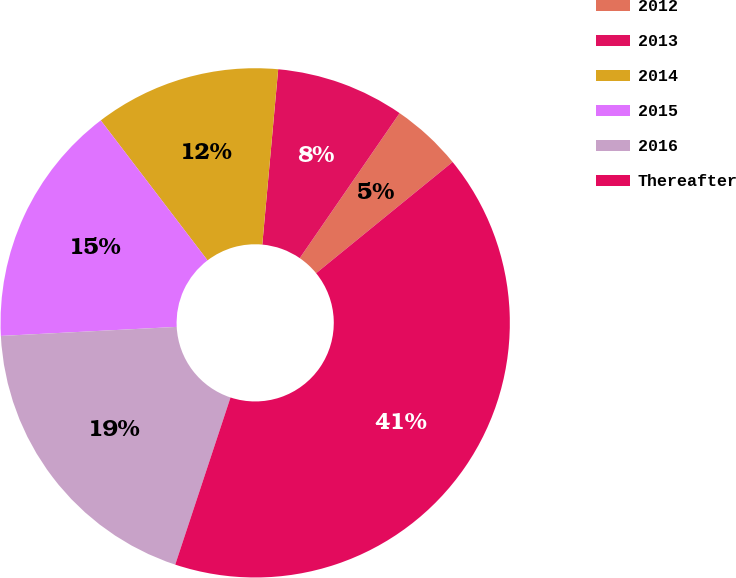Convert chart to OTSL. <chart><loc_0><loc_0><loc_500><loc_500><pie_chart><fcel>2012<fcel>2013<fcel>2014<fcel>2015<fcel>2016<fcel>Thereafter<nl><fcel>4.52%<fcel>8.16%<fcel>11.81%<fcel>15.45%<fcel>19.1%<fcel>40.97%<nl></chart> 